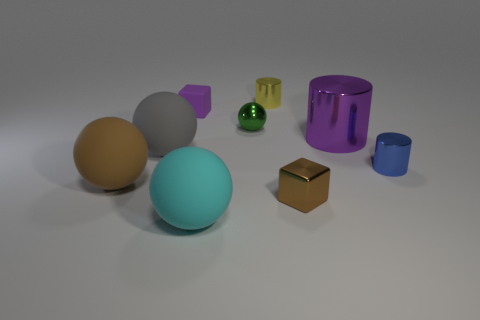Add 1 metallic balls. How many objects exist? 10 Subtract all blocks. How many objects are left? 7 Add 9 small rubber things. How many small rubber things exist? 10 Subtract 0 yellow spheres. How many objects are left? 9 Subtract all small yellow matte blocks. Subtract all gray matte things. How many objects are left? 8 Add 6 metal cylinders. How many metal cylinders are left? 9 